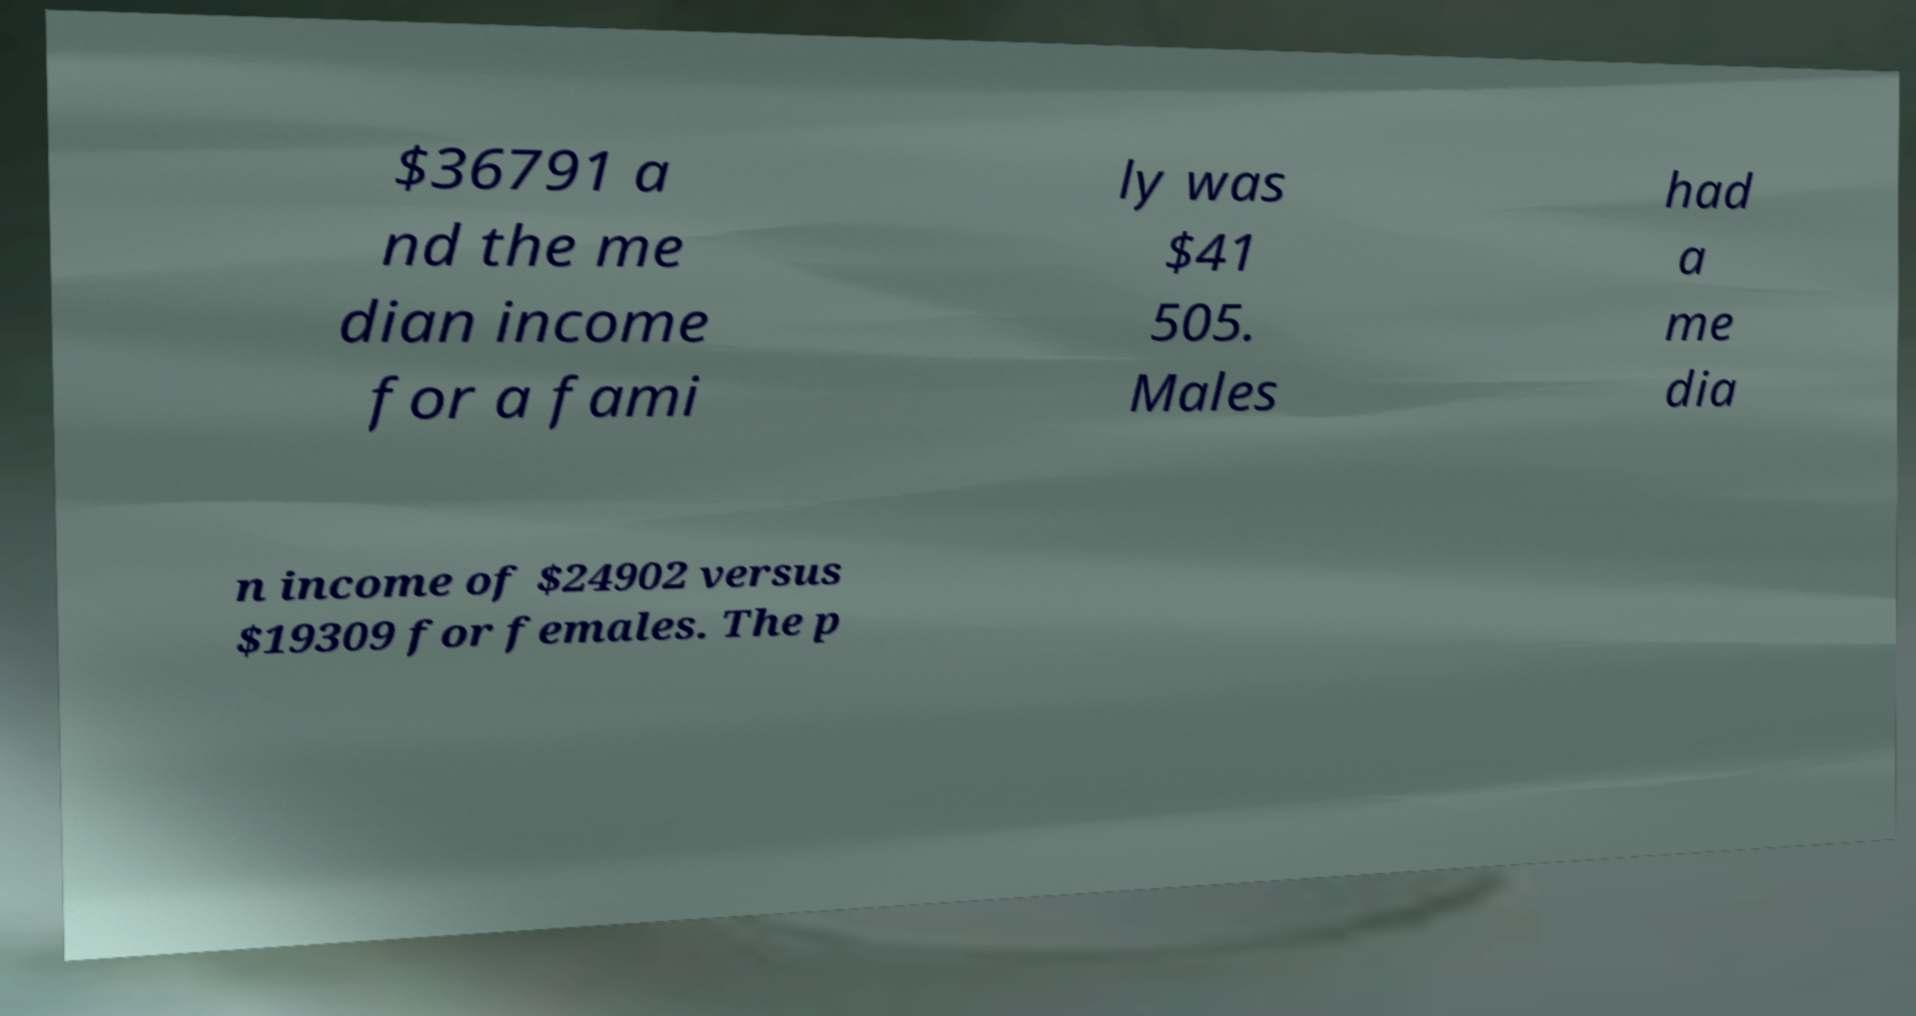For documentation purposes, I need the text within this image transcribed. Could you provide that? $36791 a nd the me dian income for a fami ly was $41 505. Males had a me dia n income of $24902 versus $19309 for females. The p 